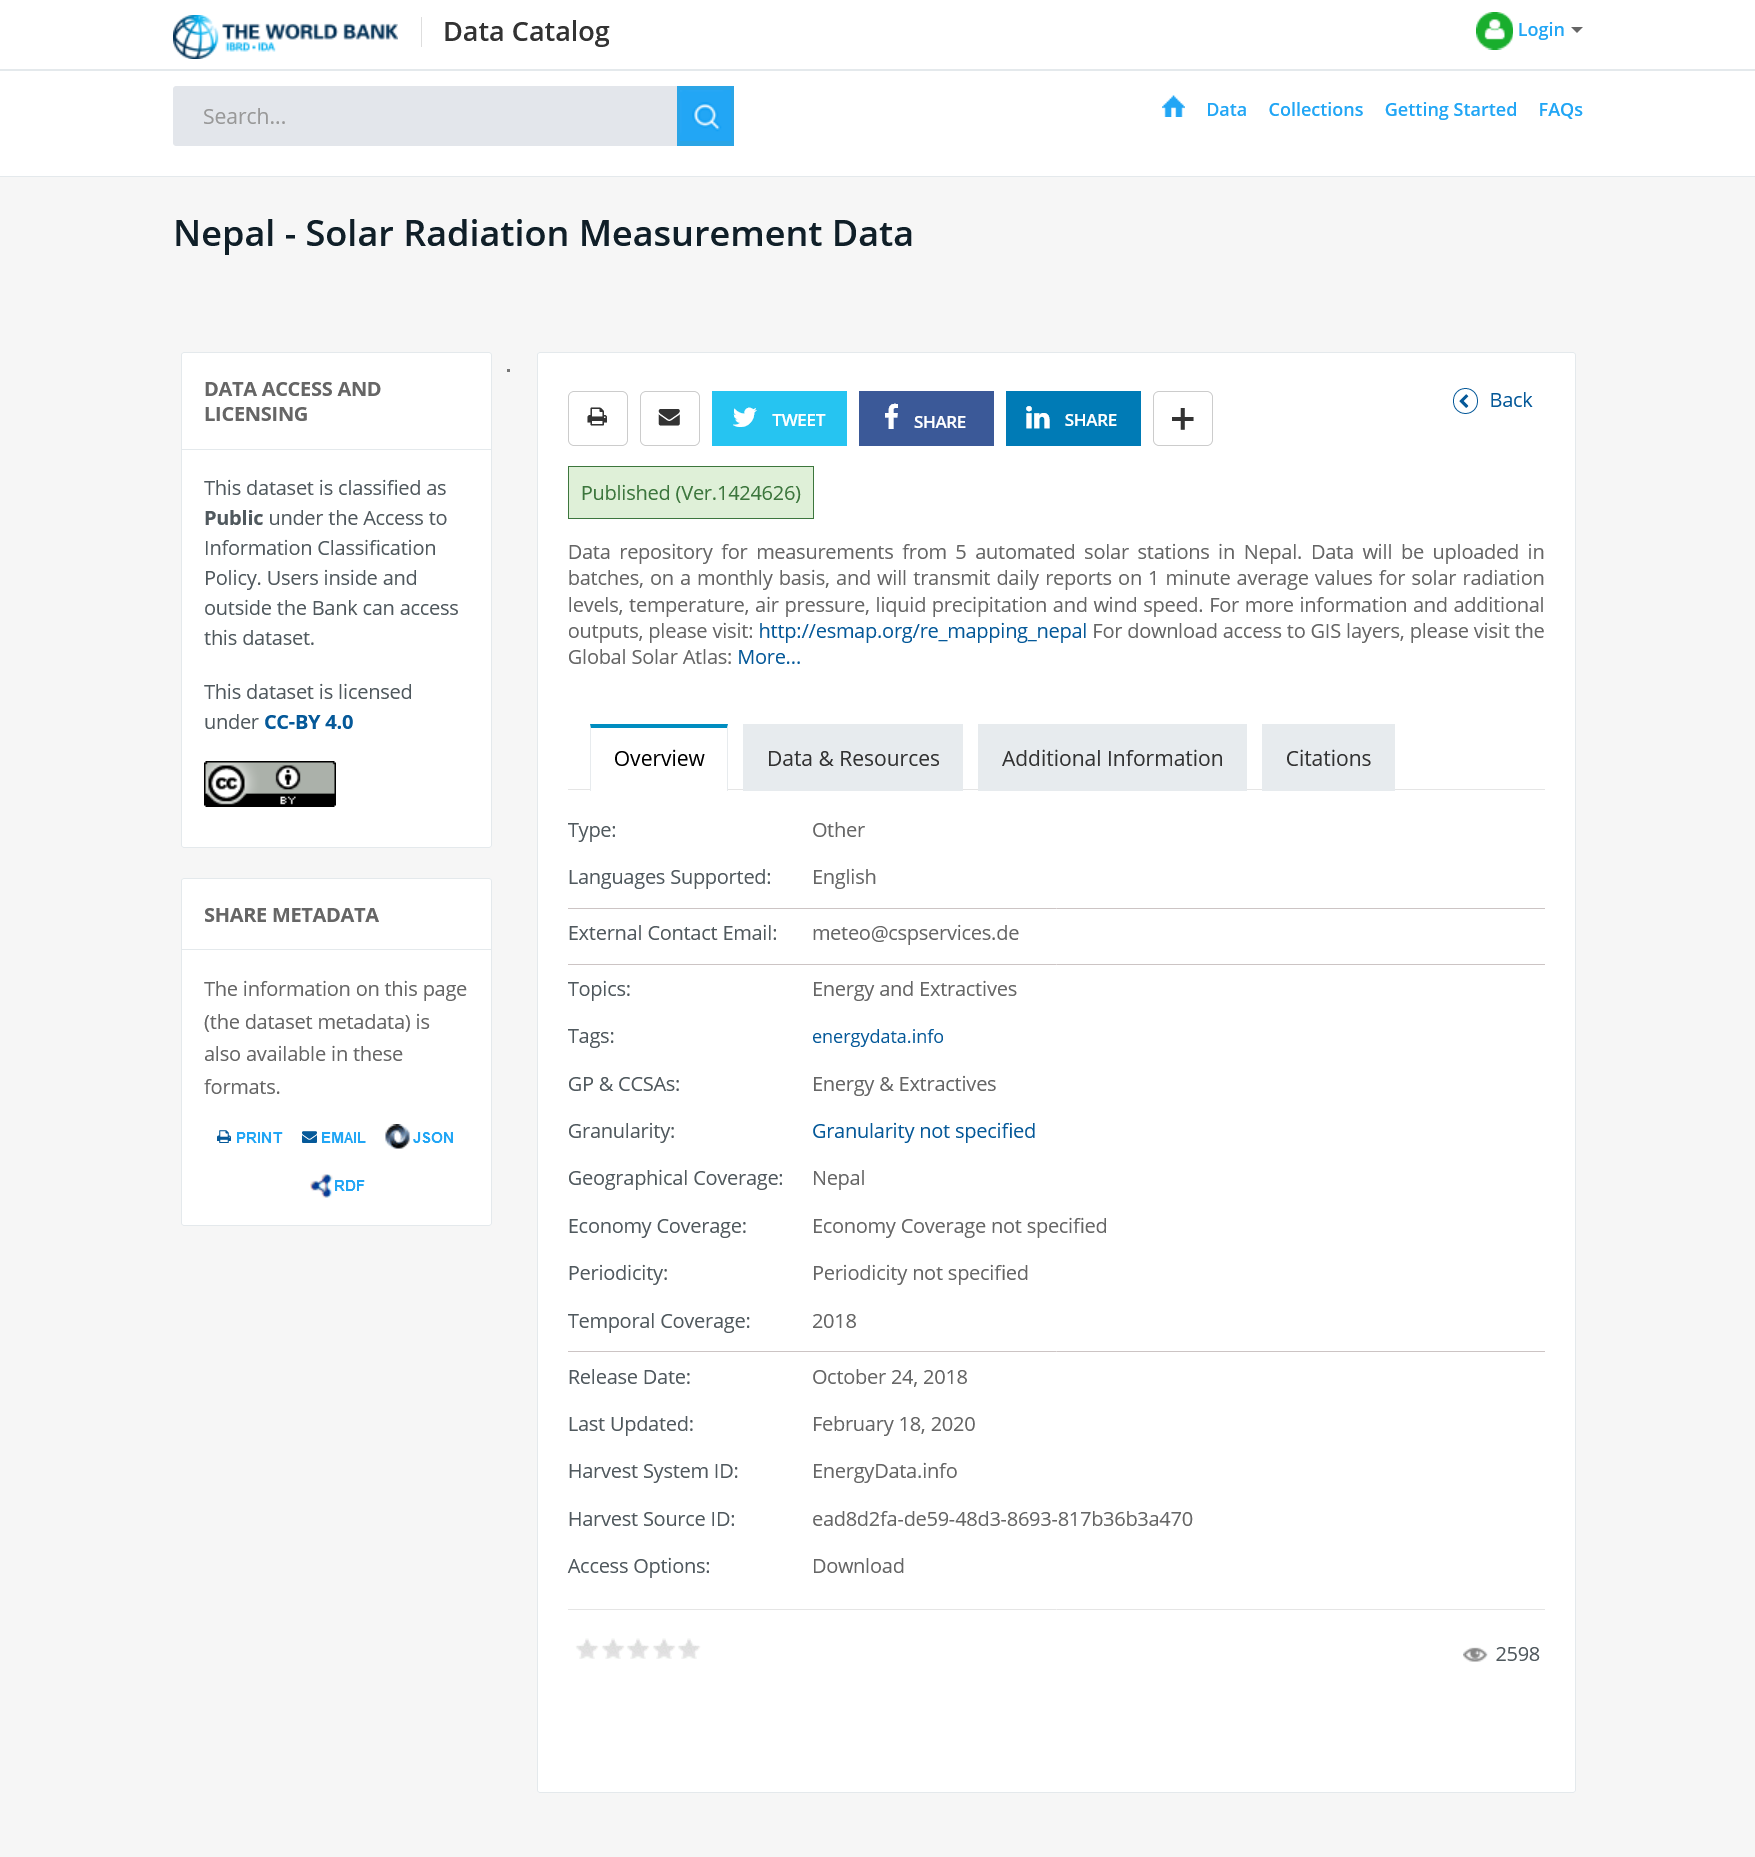Identify some key points in this picture. Data is uploaded on a monthly basis. The solar stations are primarily automated, with minimal human intervention required. The data repository for measurements from solar stations in Nepal is classified as public. 